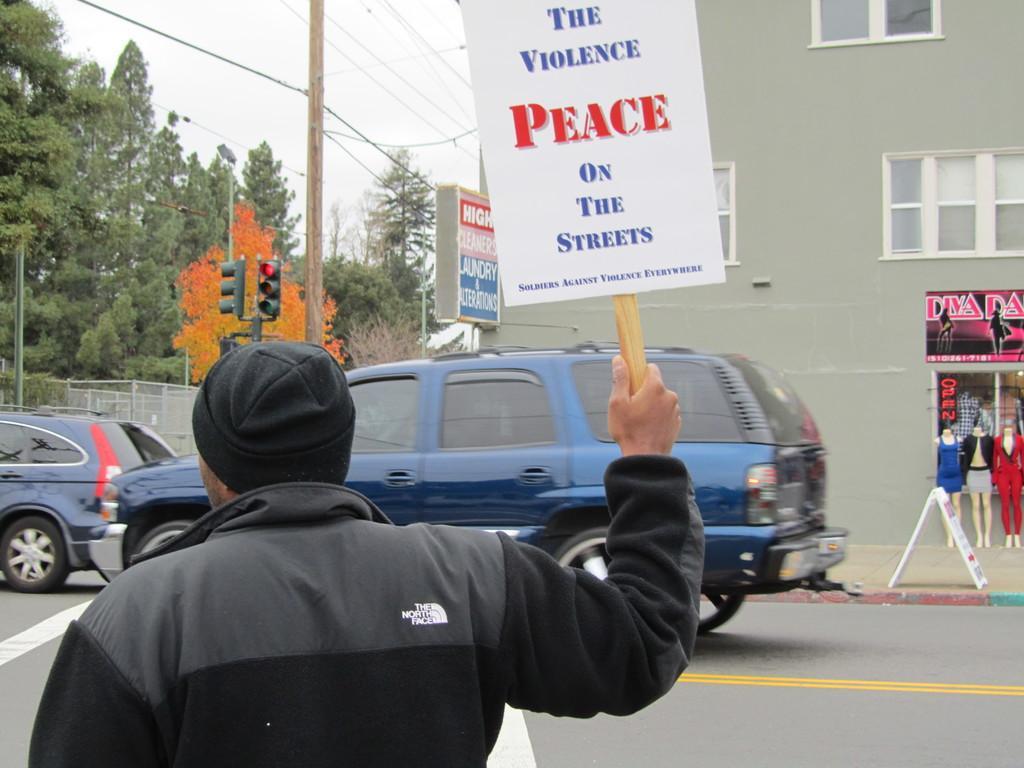Could you give a brief overview of what you see in this image? This picture is taken on the wide road. In this image, on the left side, we can see a man wearing a black color shirt and holding a board in his hand. On the right side, we can see a building, hoarding, board, in, the board, we can see some text written on it. In the background, we can see some vehicles moving on the road, traffic signal, wood pole, hoarding, trees, electric wires, metal grill, metal rod. At the top, we can see a sky, at the bottom, we can see a footpath and a road. 